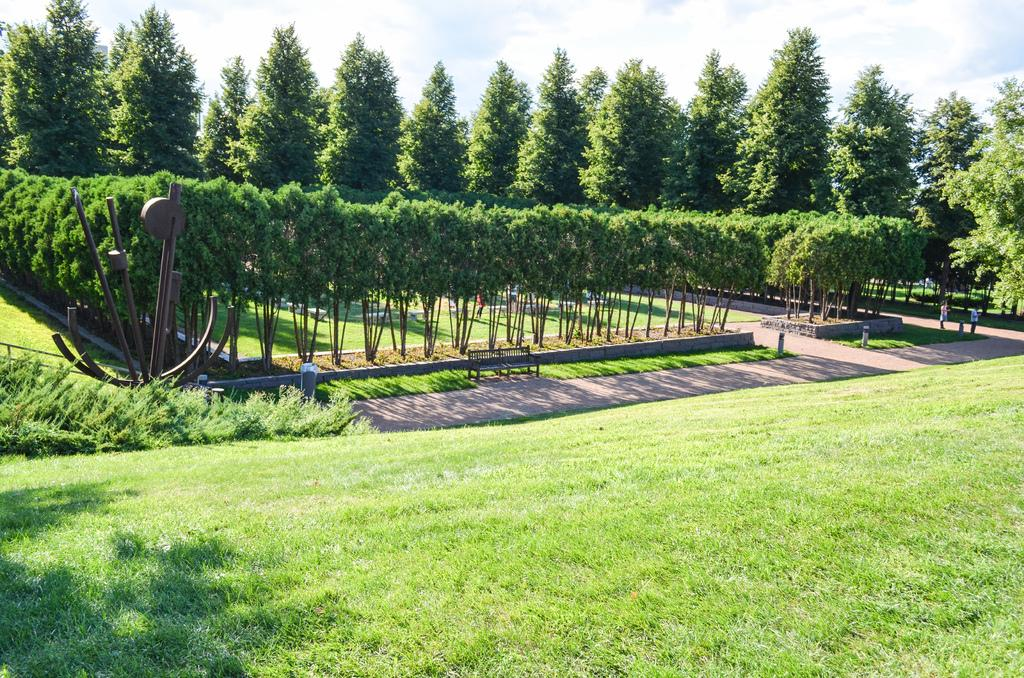What type of vegetation is present on the ground in the center of the image? There is grass on the ground in the center of the image. What can be seen in the background of the image? There are trees in the background of the image. How would you describe the sky in the image? The sky is cloudy in the image. What object is located in the center of the image? There is an empty bench in the center of the image. Are there any people in the image? Yes, there are persons present in the image. Where is the store located in the image? There is no store present in the image. What type of bulb is used to light up the area in the image? There is no mention of any bulbs or lighting in the image. 